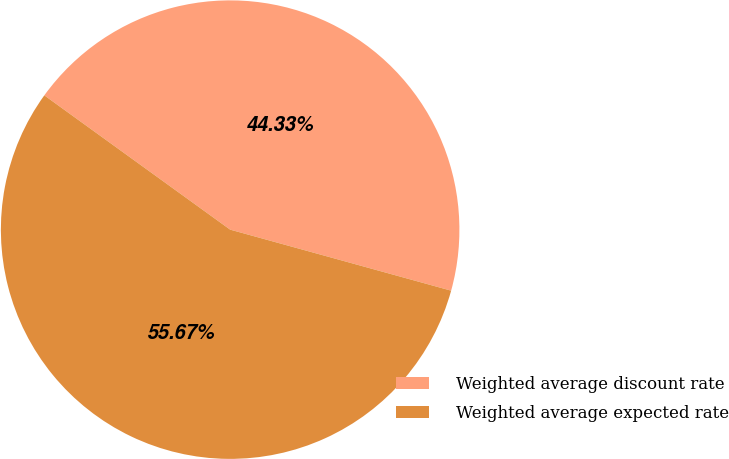<chart> <loc_0><loc_0><loc_500><loc_500><pie_chart><fcel>Weighted average discount rate<fcel>Weighted average expected rate<nl><fcel>44.33%<fcel>55.67%<nl></chart> 